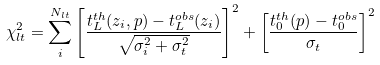<formula> <loc_0><loc_0><loc_500><loc_500>\chi _ { l t } ^ { 2 } = \sum _ { i } ^ { N _ { l t } } { \left [ \frac { t _ { L } ^ { t h } ( z _ { i } , { p } ) - t _ { L } ^ { o b s } ( z _ { i } ) } { \sqrt { \sigma _ { i } ^ { 2 } + \sigma _ { t } ^ { 2 } } } \right ] ^ { 2 } } + \left [ \frac { t _ { 0 } ^ { t h } ( { p } ) - t _ { 0 } ^ { o b s } } { \sigma _ { t } } \right ] ^ { 2 }</formula> 